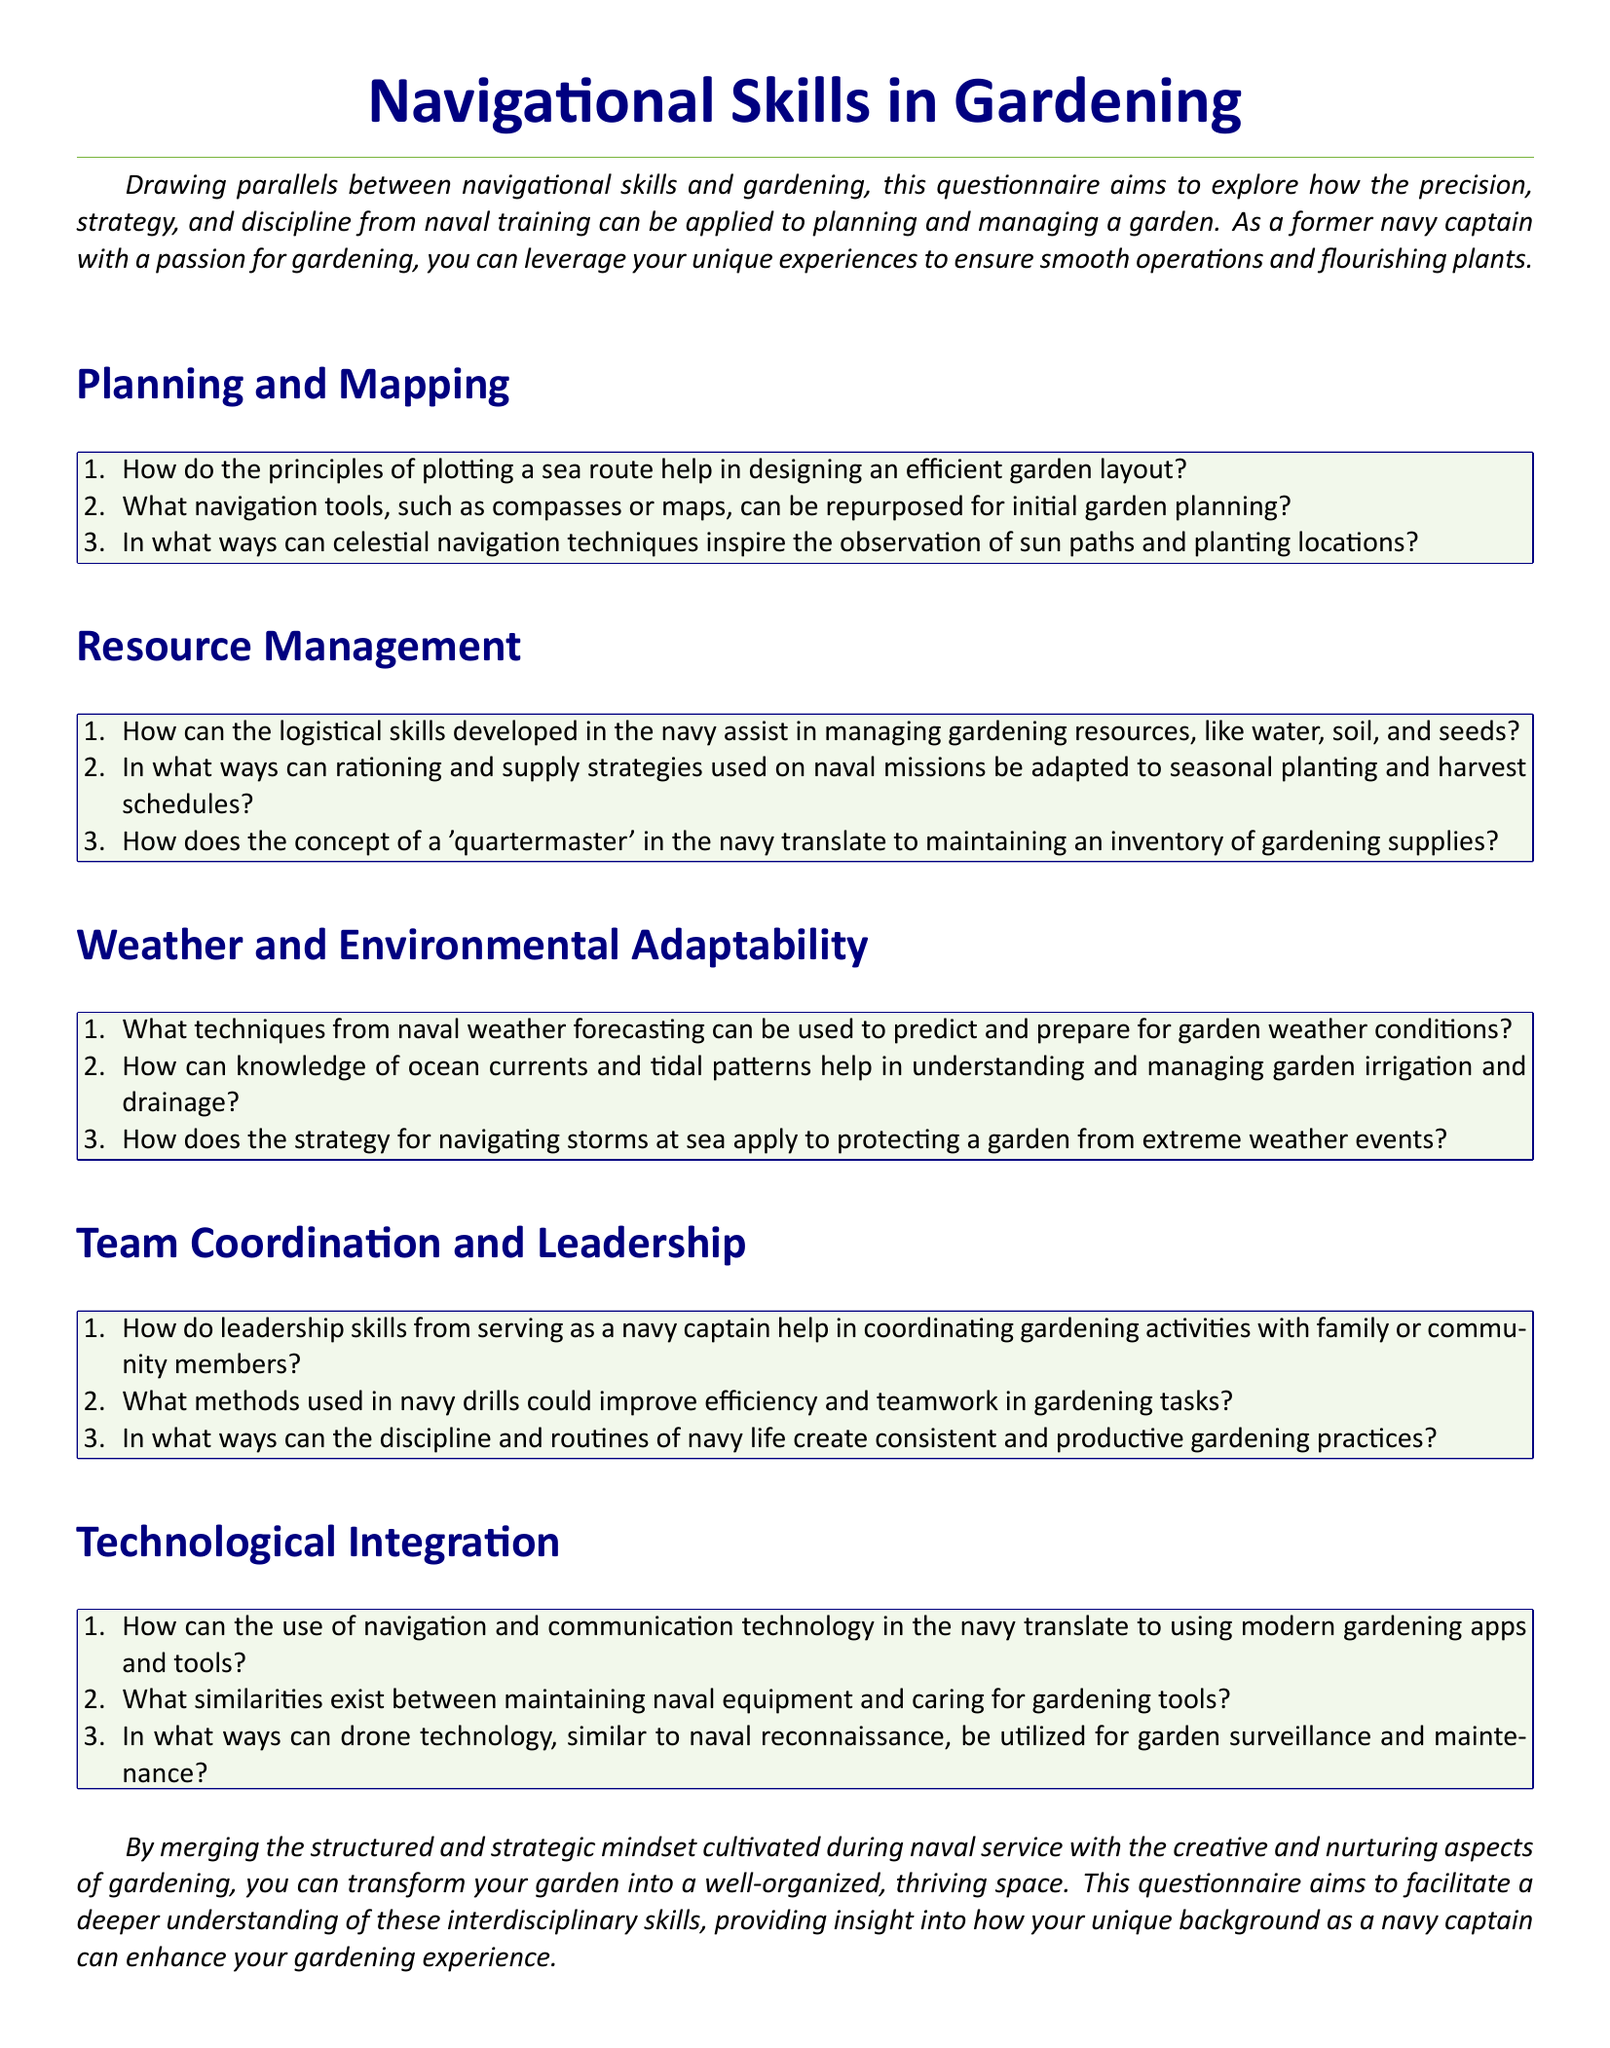What is the title of the questionnaire? The title is found at the top of the document and describes the main focus of the content.
Answer: Navigational Skills in Gardening How many sections are included in the questionnaire? The document outlines multiple sections, each addressing different topics related to gardening and naval skills.
Answer: Five What color is used for the background of the question boxes? The document specifies the color scheme for the question boxes to enhance readability.
Answer: Leaf green Which naval role is mentioned as a parallel to gardening practices? The questionnaire draws on the personal experience of the author to compare skills acquired in naval service with gardening activities.
Answer: Navy captain What type of skills does the section on Team Coordination and Leadership focus on? This section discusses how leadership skills translate into gardening contexts, emphasizing collaboration and discipline.
Answer: Leadership skills How does the questionnaire suggest adapting logistical skills from the navy? The questionnaire poses questions on resource management in gardening, paralleling logistical experiences from naval missions.
Answer: Managing gardening resources What technology is compared to modern gardening tools in the document? The questionnaire draws parallels between navigation technology used in the navy and contemporary gardening applications.
Answer: Navigation and communication technology What is suggested for predicting weather conditions in the garden? The document encourages the use of forecasting techniques learned in the navy for better garden management.
Answer: Naval weather forecasting How many items are listed under the Planning and Mapping section? The document features multiple enumerated items under each section to structure its inquiry effectively.
Answer: Three 